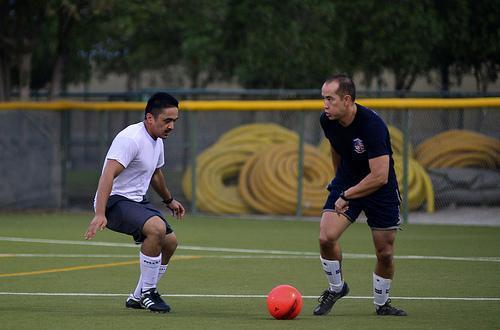How many people are in the picture?
Give a very brief answer. 2. How many balls are in the picture?
Give a very brief answer. 1. 